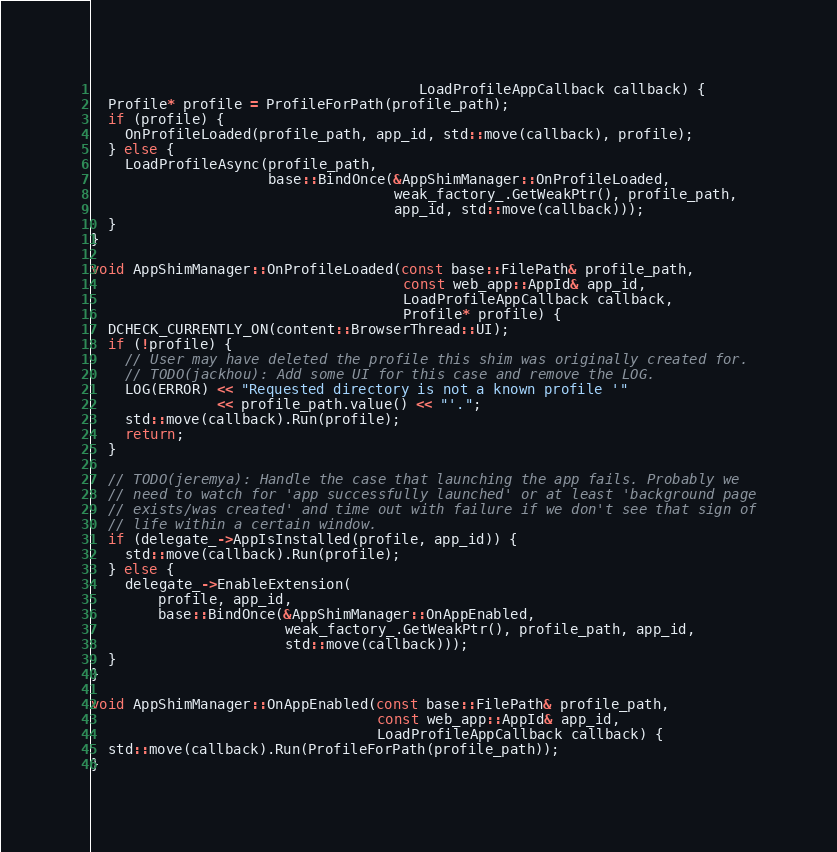Convert code to text. <code><loc_0><loc_0><loc_500><loc_500><_C++_>                                       LoadProfileAppCallback callback) {
  Profile* profile = ProfileForPath(profile_path);
  if (profile) {
    OnProfileLoaded(profile_path, app_id, std::move(callback), profile);
  } else {
    LoadProfileAsync(profile_path,
                     base::BindOnce(&AppShimManager::OnProfileLoaded,
                                    weak_factory_.GetWeakPtr(), profile_path,
                                    app_id, std::move(callback)));
  }
}

void AppShimManager::OnProfileLoaded(const base::FilePath& profile_path,
                                     const web_app::AppId& app_id,
                                     LoadProfileAppCallback callback,
                                     Profile* profile) {
  DCHECK_CURRENTLY_ON(content::BrowserThread::UI);
  if (!profile) {
    // User may have deleted the profile this shim was originally created for.
    // TODO(jackhou): Add some UI for this case and remove the LOG.
    LOG(ERROR) << "Requested directory is not a known profile '"
               << profile_path.value() << "'.";
    std::move(callback).Run(profile);
    return;
  }

  // TODO(jeremya): Handle the case that launching the app fails. Probably we
  // need to watch for 'app successfully launched' or at least 'background page
  // exists/was created' and time out with failure if we don't see that sign of
  // life within a certain window.
  if (delegate_->AppIsInstalled(profile, app_id)) {
    std::move(callback).Run(profile);
  } else {
    delegate_->EnableExtension(
        profile, app_id,
        base::BindOnce(&AppShimManager::OnAppEnabled,
                       weak_factory_.GetWeakPtr(), profile_path, app_id,
                       std::move(callback)));
  }
}

void AppShimManager::OnAppEnabled(const base::FilePath& profile_path,
                                  const web_app::AppId& app_id,
                                  LoadProfileAppCallback callback) {
  std::move(callback).Run(ProfileForPath(profile_path));
}
</code> 